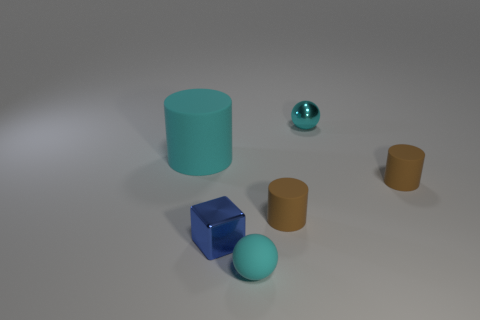Subtract all red cylinders. Subtract all blue balls. How many cylinders are left? 3 Add 3 big blue cubes. How many objects exist? 9 Subtract all balls. How many objects are left? 4 Add 6 red metallic spheres. How many red metallic spheres exist? 6 Subtract 0 gray cylinders. How many objects are left? 6 Subtract all tiny green shiny blocks. Subtract all tiny balls. How many objects are left? 4 Add 2 large matte things. How many large matte things are left? 3 